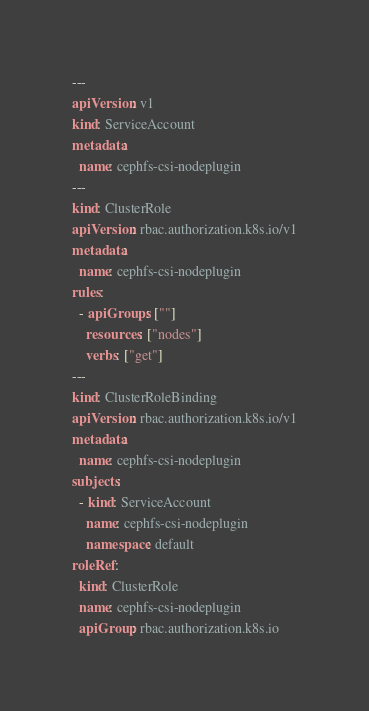<code> <loc_0><loc_0><loc_500><loc_500><_YAML_>---
apiVersion: v1
kind: ServiceAccount
metadata:
  name: cephfs-csi-nodeplugin
---
kind: ClusterRole
apiVersion: rbac.authorization.k8s.io/v1
metadata:
  name: cephfs-csi-nodeplugin
rules:
  - apiGroups: [""]
    resources: ["nodes"]
    verbs: ["get"]
---
kind: ClusterRoleBinding
apiVersion: rbac.authorization.k8s.io/v1
metadata:
  name: cephfs-csi-nodeplugin
subjects:
  - kind: ServiceAccount
    name: cephfs-csi-nodeplugin
    namespace: default
roleRef:
  kind: ClusterRole
  name: cephfs-csi-nodeplugin
  apiGroup: rbac.authorization.k8s.io
</code> 